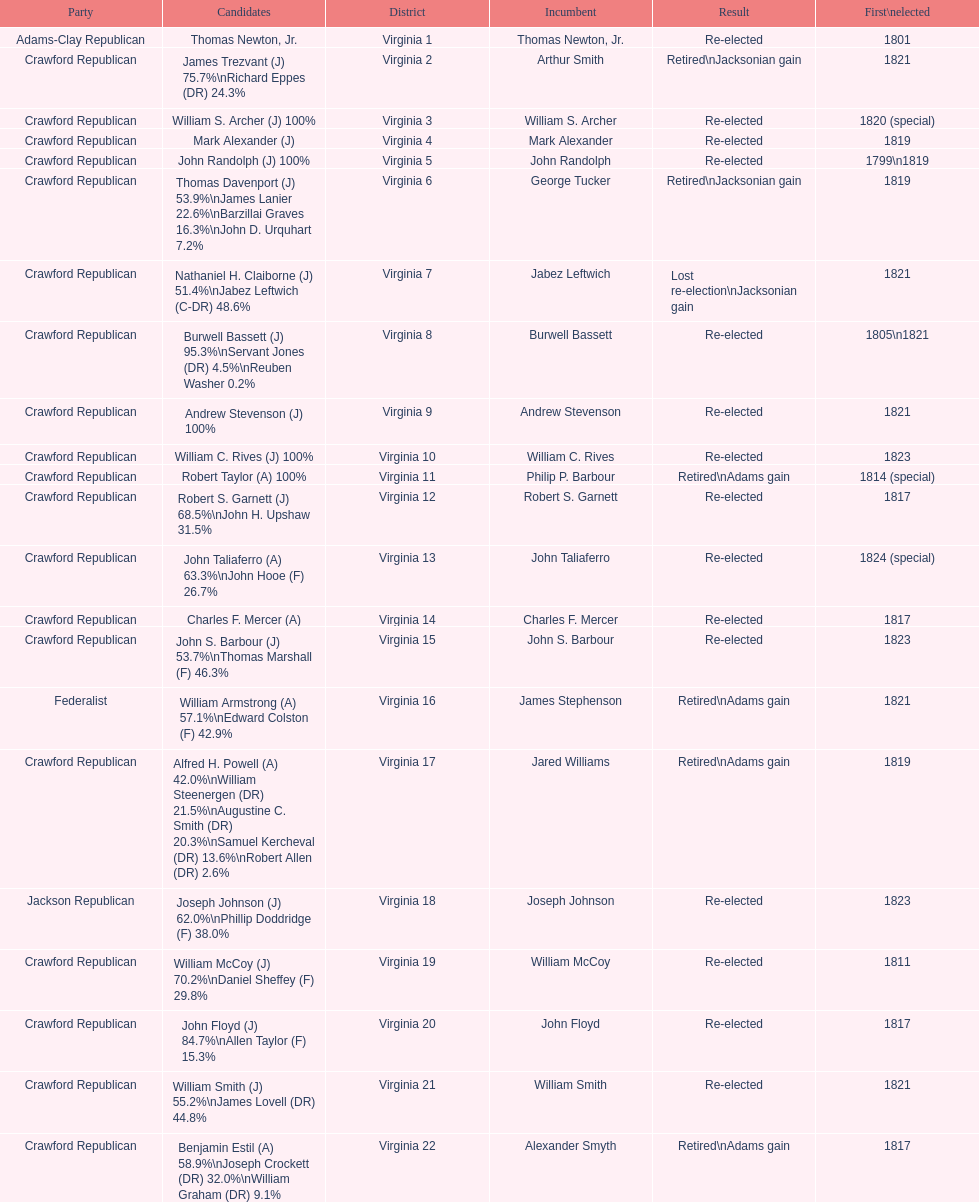Name the only candidate that was first elected in 1811. William McCoy. 